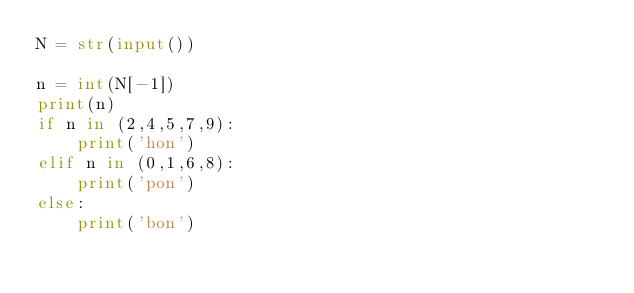Convert code to text. <code><loc_0><loc_0><loc_500><loc_500><_Python_>N = str(input())

n = int(N[-1])
print(n)
if n in (2,4,5,7,9):
    print('hon')
elif n in (0,1,6,8):
    print('pon')
else:
    print('bon')</code> 